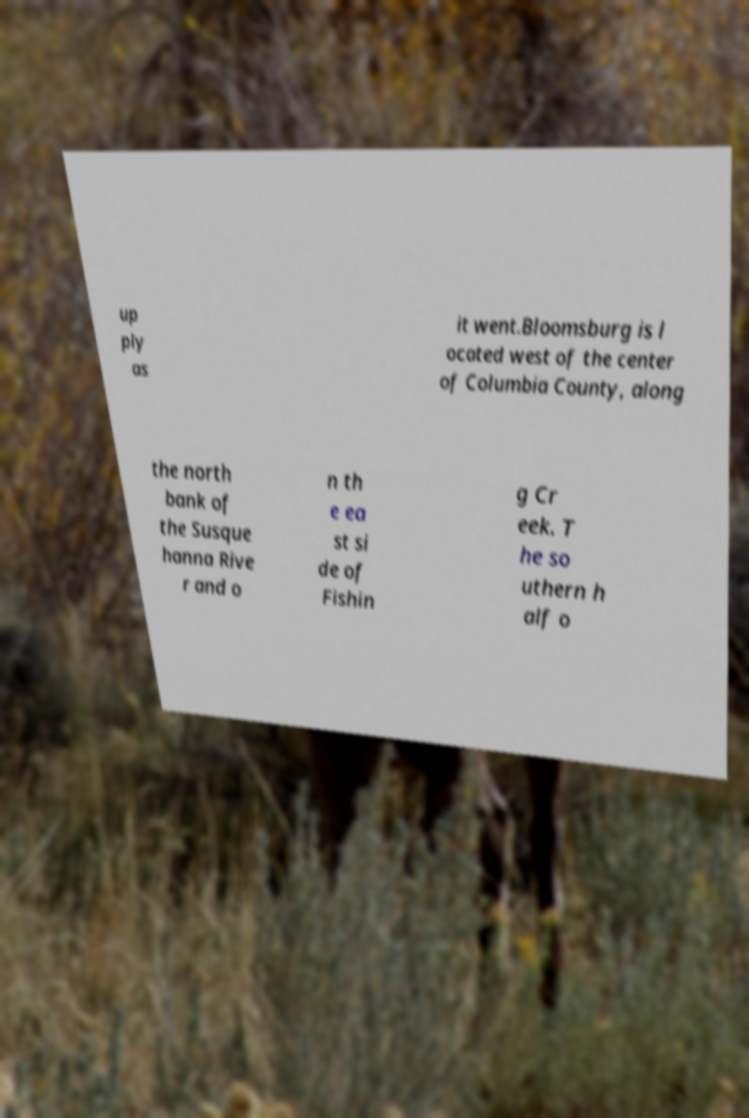There's text embedded in this image that I need extracted. Can you transcribe it verbatim? up ply as it went.Bloomsburg is l ocated west of the center of Columbia County, along the north bank of the Susque hanna Rive r and o n th e ea st si de of Fishin g Cr eek. T he so uthern h alf o 